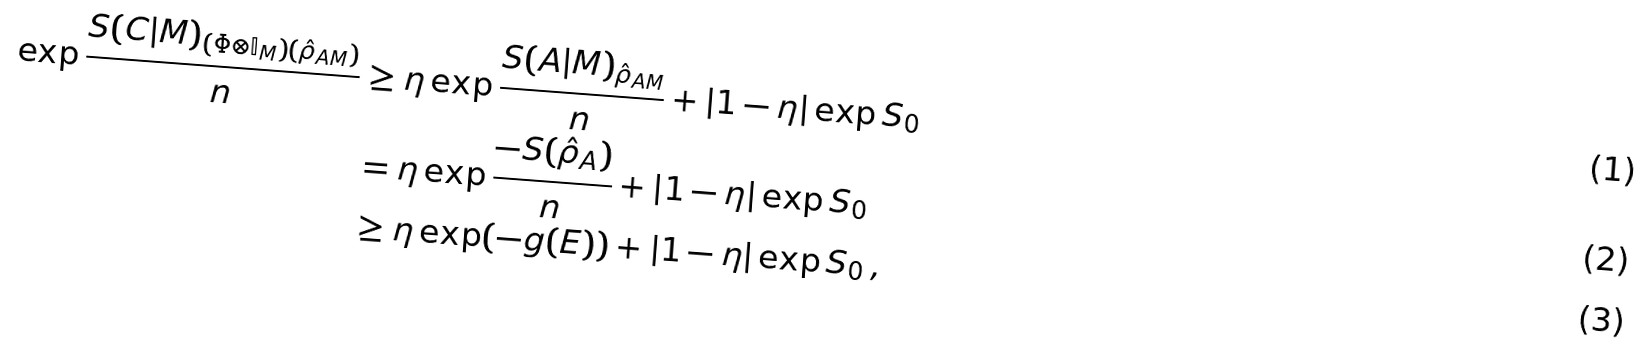<formula> <loc_0><loc_0><loc_500><loc_500>\exp \frac { S ( C | M ) _ { ( \Phi \otimes \mathbb { I } _ { M } ) ( \hat { \rho } _ { A M } ) } } { n } & \geq \eta \exp \frac { S ( A | M ) _ { \hat { \rho } _ { A M } } } { n } + \left | 1 - \eta \right | \exp S _ { 0 } \\ & = \eta \exp \frac { - S ( \hat { \rho } _ { A } ) } { n } + \left | 1 - \eta \right | \exp S _ { 0 } \\ & \geq \eta \exp ( - g ( E ) ) + \left | 1 - \eta \right | \exp S _ { 0 } \, ,</formula> 